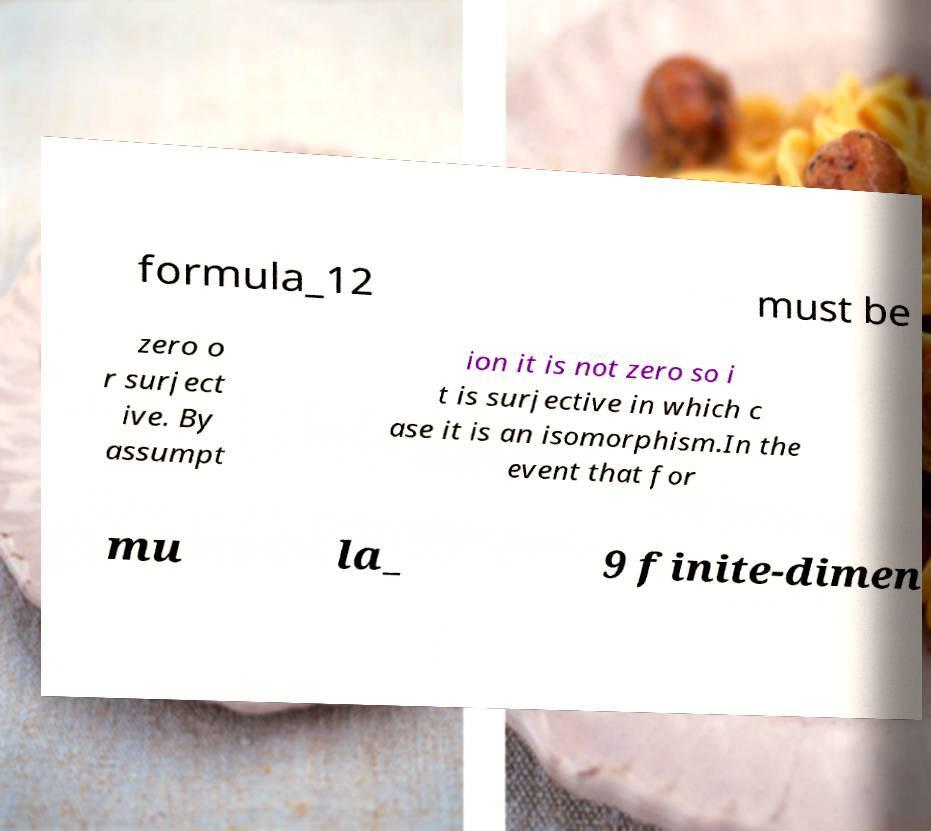What messages or text are displayed in this image? I need them in a readable, typed format. formula_12 must be zero o r surject ive. By assumpt ion it is not zero so i t is surjective in which c ase it is an isomorphism.In the event that for mu la_ 9 finite-dimen 